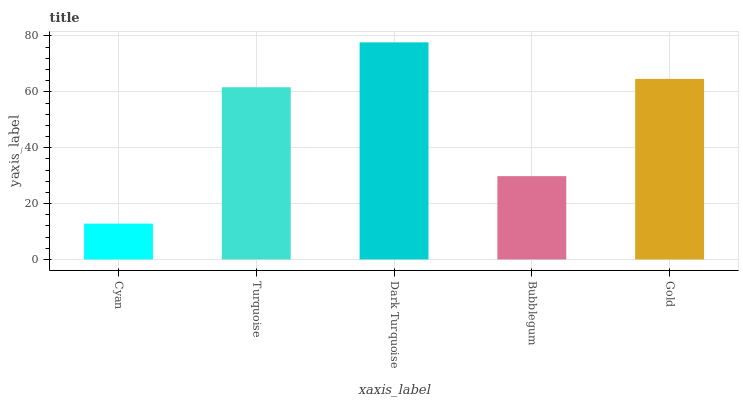Is Cyan the minimum?
Answer yes or no. Yes. Is Dark Turquoise the maximum?
Answer yes or no. Yes. Is Turquoise the minimum?
Answer yes or no. No. Is Turquoise the maximum?
Answer yes or no. No. Is Turquoise greater than Cyan?
Answer yes or no. Yes. Is Cyan less than Turquoise?
Answer yes or no. Yes. Is Cyan greater than Turquoise?
Answer yes or no. No. Is Turquoise less than Cyan?
Answer yes or no. No. Is Turquoise the high median?
Answer yes or no. Yes. Is Turquoise the low median?
Answer yes or no. Yes. Is Gold the high median?
Answer yes or no. No. Is Bubblegum the low median?
Answer yes or no. No. 